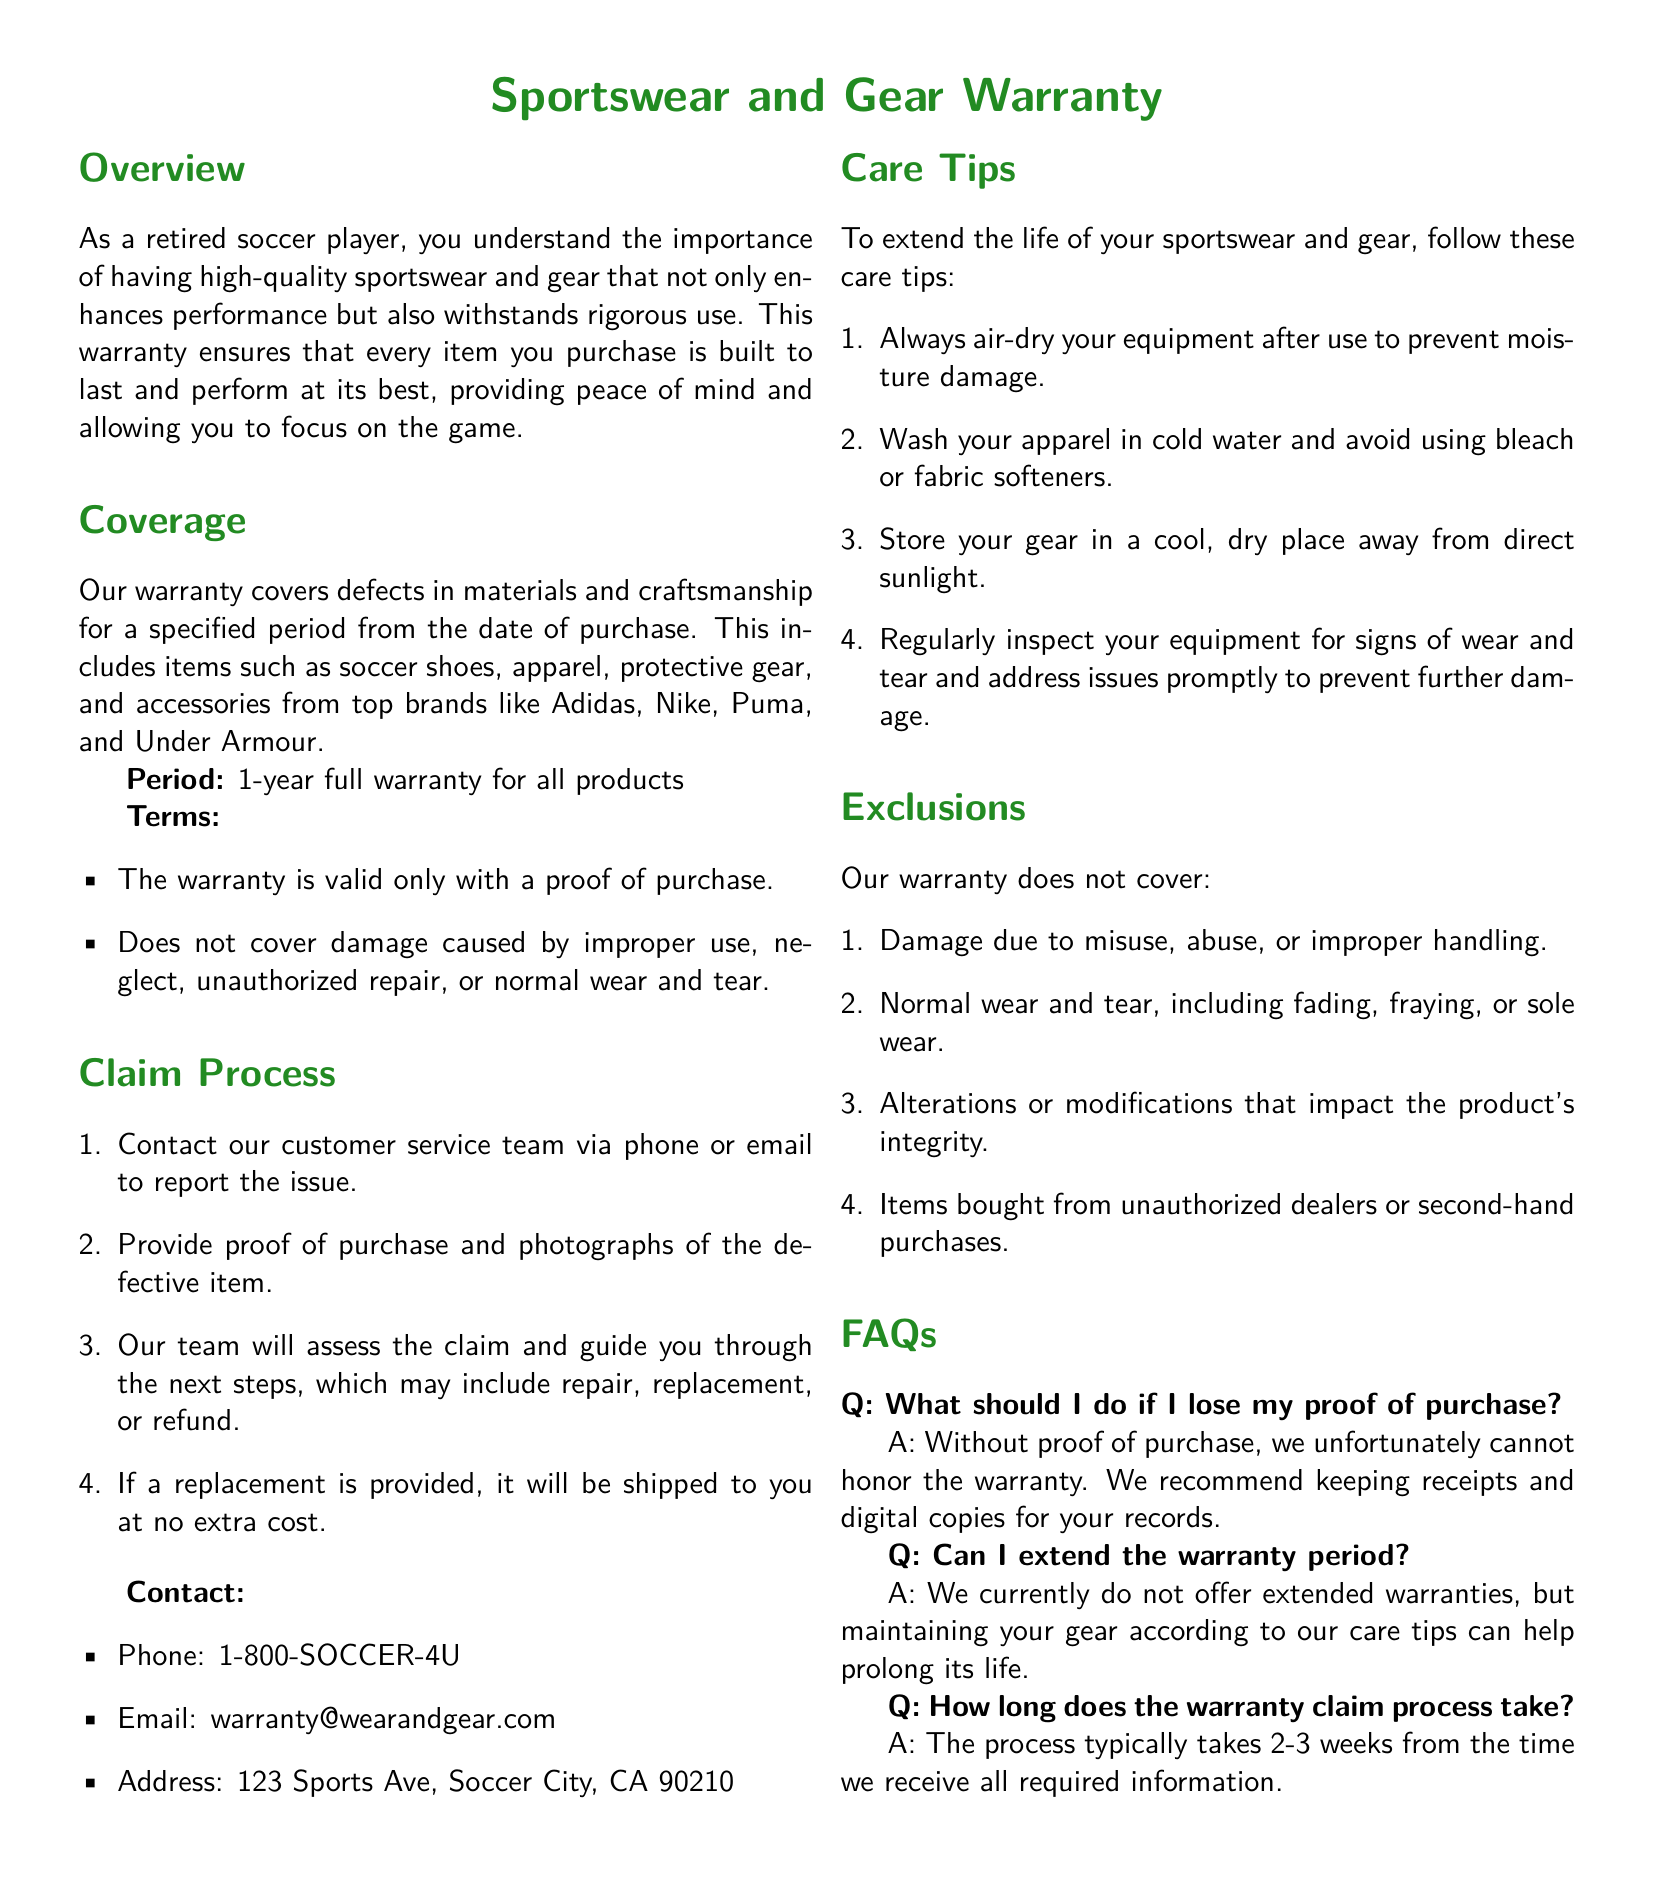What is the duration of the warranty? The document states that there is a 1-year full warranty for all products.
Answer: 1 year Which brands are covered under the warranty? The warranty includes brands such as Adidas, Nike, Puma, and Under Armour.
Answer: Adidas, Nike, Puma, Under Armour What should be provided to validate the warranty? A proof of purchase is necessary to validate the warranty, according to the terms.
Answer: Proof of purchase What is excluded from the warranty coverage? The warranty does not cover damage due to misuse, abuse, or improper handling, among other items listed.
Answer: Misuse, abuse, or improper handling How can a warranty claim be initiated? A warranty claim can be initiated by contacting the customer service team via phone or email.
Answer: Contact customer service What is the typical processing time for a warranty claim? The document mentions that the warranty claim process takes typically 2-3 weeks.
Answer: 2-3 weeks Are alterations covered under the warranty? It specifies that alterations or modifications impact the product's integrity and are excluded from coverage.
Answer: No Where can customer service be contacted? The document provides a phone number, email, and address for customer service.
Answer: 1-800-SOCCER-4U, warranty@wearandgear.com What should be done with gear after use? It states that equipment should always be air-dried after use to prevent moisture damage.
Answer: Air-dry equipment 